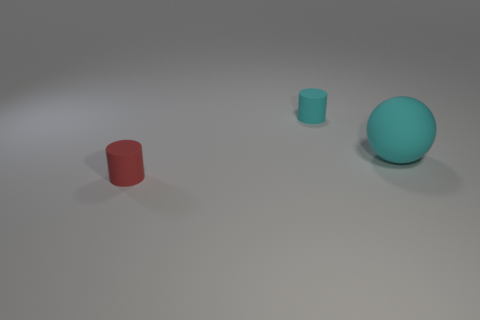Add 3 tiny rubber cylinders. How many objects exist? 6 Subtract all cylinders. How many objects are left? 1 Add 3 large things. How many large things exist? 4 Subtract 0 yellow spheres. How many objects are left? 3 Subtract all blue spheres. Subtract all big cyan balls. How many objects are left? 2 Add 1 small rubber cylinders. How many small rubber cylinders are left? 3 